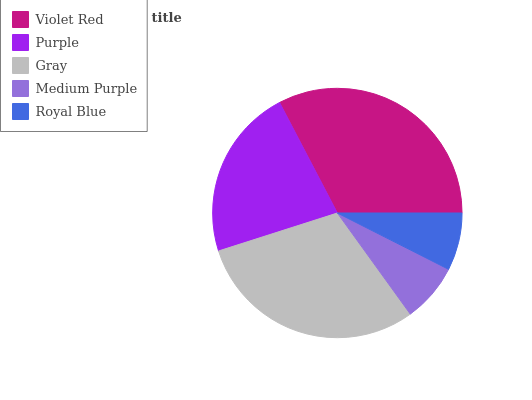Is Royal Blue the minimum?
Answer yes or no. Yes. Is Violet Red the maximum?
Answer yes or no. Yes. Is Purple the minimum?
Answer yes or no. No. Is Purple the maximum?
Answer yes or no. No. Is Violet Red greater than Purple?
Answer yes or no. Yes. Is Purple less than Violet Red?
Answer yes or no. Yes. Is Purple greater than Violet Red?
Answer yes or no. No. Is Violet Red less than Purple?
Answer yes or no. No. Is Purple the high median?
Answer yes or no. Yes. Is Purple the low median?
Answer yes or no. Yes. Is Gray the high median?
Answer yes or no. No. Is Medium Purple the low median?
Answer yes or no. No. 